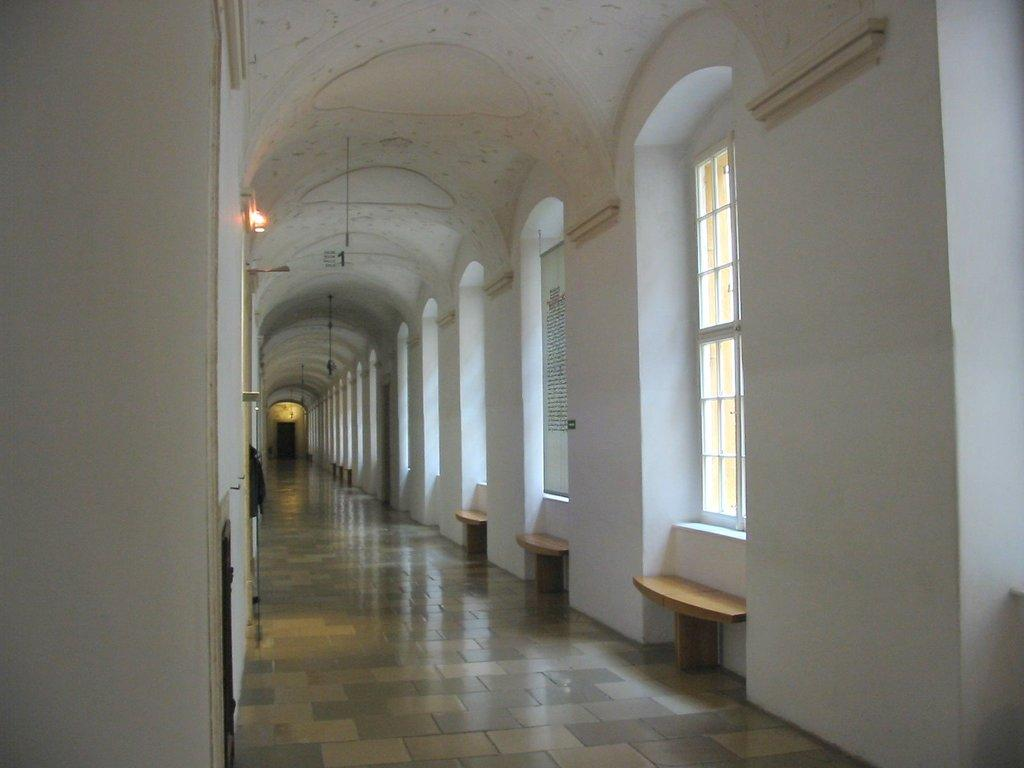What type of surface is visible in the image? The image contains a floor. What is one of the vertical structures in the image? There is a wall in the image. What allows light to enter the room in the image? There is a window in the image. What provides illumination in the image? There is a light in the image. What can be seen in the image besides the floor, wall, window, and light? There are objects in the image. What is visible in the background of the image? There is a roof visible in the background of the image. Can you tell me how many pairs of scissors are being used to run a trick in the image? There are no scissors, running, or tricks present in the image. 